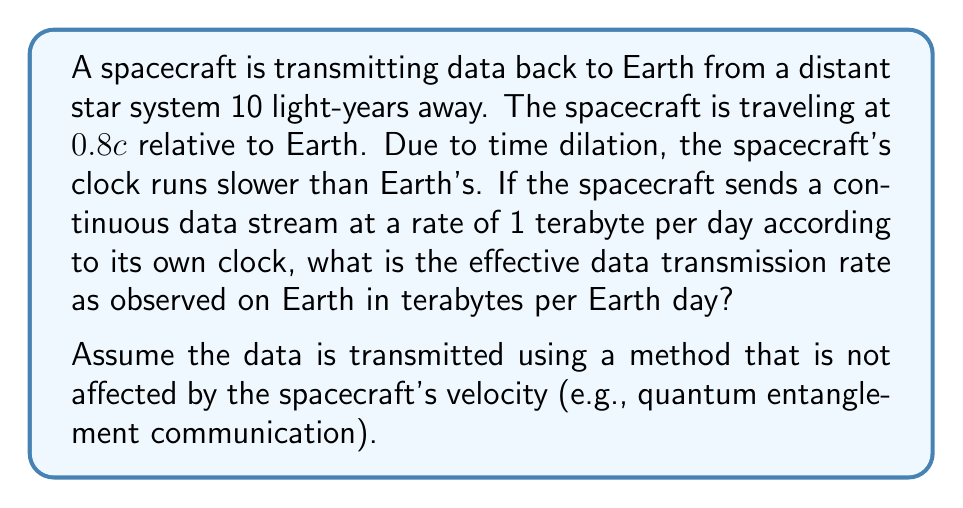Can you answer this question? To solve this problem, we need to consider the effects of special relativity, particularly time dilation. Let's approach this step-by-step:

1) First, we need to calculate the time dilation factor. The Lorentz factor (γ) is given by:

   $$\gamma = \frac{1}{\sqrt{1 - \frac{v^2}{c^2}}}$$

   where v is the velocity of the spacecraft and c is the speed of light.

2) Given v = 0.8c, we can calculate γ:

   $$\gamma = \frac{1}{\sqrt{1 - \frac{(0.8c)^2}{c^2}}} = \frac{1}{\sqrt{1 - 0.64}} = \frac{1}{\sqrt{0.36}} = \frac{1}{0.6} = \frac{5}{3} \approx 1.67$$

3) Time dilation means that for every 1 day that passes on the spacecraft, more time passes on Earth. The relation is:

   $$t_{Earth} = \gamma \cdot t_{spacecraft}$$

4) So, for every 1 day on the spacecraft, 1.67 days pass on Earth.

5) The spacecraft sends 1 terabyte per spacecraft day. To find the rate in Earth days, we divide by the time dilation factor:

   $$\text{Rate}_{\text{Earth}} = \frac{\text{Rate}_{\text{spacecraft}}}{\gamma} = \frac{1 \text{ TB/day}}{5/3} = \frac{3}{5} \text{ TB/Earth day} = 0.6 \text{ TB/Earth day}$$

Therefore, from Earth's perspective, the spacecraft is transmitting data at a rate of 0.6 terabytes per Earth day.
Answer: The effective data transmission rate as observed on Earth is 0.6 terabytes per Earth day. 